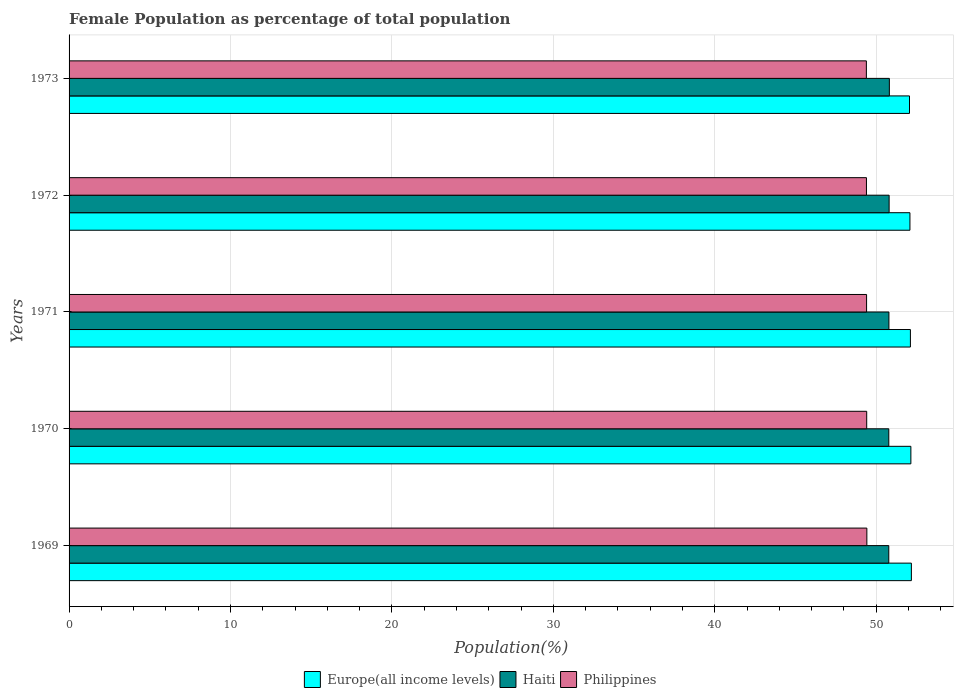How many different coloured bars are there?
Make the answer very short. 3. Are the number of bars per tick equal to the number of legend labels?
Provide a short and direct response. Yes. Are the number of bars on each tick of the Y-axis equal?
Provide a succinct answer. Yes. How many bars are there on the 5th tick from the bottom?
Keep it short and to the point. 3. In how many cases, is the number of bars for a given year not equal to the number of legend labels?
Make the answer very short. 0. What is the female population in in Haiti in 1970?
Your answer should be very brief. 50.78. Across all years, what is the maximum female population in in Philippines?
Give a very brief answer. 49.42. Across all years, what is the minimum female population in in Philippines?
Offer a terse response. 49.39. In which year was the female population in in Europe(all income levels) maximum?
Provide a succinct answer. 1969. In which year was the female population in in Philippines minimum?
Provide a short and direct response. 1973. What is the total female population in in Europe(all income levels) in the graph?
Make the answer very short. 260.58. What is the difference between the female population in in Philippines in 1971 and that in 1973?
Your answer should be compact. 0.01. What is the difference between the female population in in Philippines in 1973 and the female population in in Haiti in 1972?
Your answer should be very brief. -1.41. What is the average female population in in Europe(all income levels) per year?
Offer a terse response. 52.12. In the year 1969, what is the difference between the female population in in Europe(all income levels) and female population in in Haiti?
Offer a terse response. 1.4. In how many years, is the female population in in Philippines greater than 26 %?
Ensure brevity in your answer.  5. What is the ratio of the female population in in Philippines in 1969 to that in 1970?
Ensure brevity in your answer.  1. What is the difference between the highest and the second highest female population in in Philippines?
Your answer should be compact. 0.01. What is the difference between the highest and the lowest female population in in Haiti?
Give a very brief answer. 0.04. In how many years, is the female population in in Philippines greater than the average female population in in Philippines taken over all years?
Give a very brief answer. 2. What does the 2nd bar from the top in 1973 represents?
Your response must be concise. Haiti. What does the 2nd bar from the bottom in 1970 represents?
Your answer should be compact. Haiti. How many bars are there?
Give a very brief answer. 15. Are all the bars in the graph horizontal?
Ensure brevity in your answer.  Yes. How many years are there in the graph?
Ensure brevity in your answer.  5. What is the difference between two consecutive major ticks on the X-axis?
Keep it short and to the point. 10. Does the graph contain grids?
Ensure brevity in your answer.  Yes. How many legend labels are there?
Make the answer very short. 3. How are the legend labels stacked?
Your answer should be very brief. Horizontal. What is the title of the graph?
Your answer should be very brief. Female Population as percentage of total population. What is the label or title of the X-axis?
Your answer should be compact. Population(%). What is the label or title of the Y-axis?
Make the answer very short. Years. What is the Population(%) of Europe(all income levels) in 1969?
Offer a terse response. 52.18. What is the Population(%) of Haiti in 1969?
Provide a short and direct response. 50.78. What is the Population(%) in Philippines in 1969?
Make the answer very short. 49.42. What is the Population(%) of Europe(all income levels) in 1970?
Offer a very short reply. 52.15. What is the Population(%) in Haiti in 1970?
Your response must be concise. 50.78. What is the Population(%) of Philippines in 1970?
Your answer should be compact. 49.41. What is the Population(%) in Europe(all income levels) in 1971?
Ensure brevity in your answer.  52.12. What is the Population(%) in Haiti in 1971?
Your answer should be very brief. 50.79. What is the Population(%) in Philippines in 1971?
Offer a very short reply. 49.4. What is the Population(%) of Europe(all income levels) in 1972?
Provide a succinct answer. 52.09. What is the Population(%) of Haiti in 1972?
Provide a succinct answer. 50.8. What is the Population(%) in Philippines in 1972?
Give a very brief answer. 49.39. What is the Population(%) of Europe(all income levels) in 1973?
Your answer should be compact. 52.06. What is the Population(%) of Haiti in 1973?
Keep it short and to the point. 50.81. What is the Population(%) of Philippines in 1973?
Your answer should be compact. 49.39. Across all years, what is the maximum Population(%) in Europe(all income levels)?
Give a very brief answer. 52.18. Across all years, what is the maximum Population(%) in Haiti?
Your answer should be very brief. 50.81. Across all years, what is the maximum Population(%) of Philippines?
Offer a very short reply. 49.42. Across all years, what is the minimum Population(%) of Europe(all income levels)?
Ensure brevity in your answer.  52.06. Across all years, what is the minimum Population(%) of Haiti?
Provide a succinct answer. 50.78. Across all years, what is the minimum Population(%) of Philippines?
Ensure brevity in your answer.  49.39. What is the total Population(%) of Europe(all income levels) in the graph?
Keep it short and to the point. 260.58. What is the total Population(%) in Haiti in the graph?
Provide a succinct answer. 253.95. What is the total Population(%) of Philippines in the graph?
Give a very brief answer. 247.01. What is the difference between the Population(%) of Europe(all income levels) in 1969 and that in 1970?
Give a very brief answer. 0.03. What is the difference between the Population(%) in Haiti in 1969 and that in 1970?
Provide a short and direct response. -0. What is the difference between the Population(%) in Philippines in 1969 and that in 1970?
Provide a short and direct response. 0.01. What is the difference between the Population(%) in Europe(all income levels) in 1969 and that in 1971?
Provide a short and direct response. 0.06. What is the difference between the Population(%) in Haiti in 1969 and that in 1971?
Your response must be concise. -0.01. What is the difference between the Population(%) in Philippines in 1969 and that in 1971?
Offer a very short reply. 0.02. What is the difference between the Population(%) of Europe(all income levels) in 1969 and that in 1972?
Ensure brevity in your answer.  0.09. What is the difference between the Population(%) in Haiti in 1969 and that in 1972?
Make the answer very short. -0.02. What is the difference between the Population(%) of Philippines in 1969 and that in 1972?
Offer a terse response. 0.02. What is the difference between the Population(%) in Europe(all income levels) in 1969 and that in 1973?
Provide a succinct answer. 0.12. What is the difference between the Population(%) of Haiti in 1969 and that in 1973?
Offer a very short reply. -0.04. What is the difference between the Population(%) in Philippines in 1969 and that in 1973?
Offer a very short reply. 0.03. What is the difference between the Population(%) in Europe(all income levels) in 1970 and that in 1971?
Give a very brief answer. 0.03. What is the difference between the Population(%) of Haiti in 1970 and that in 1971?
Your answer should be compact. -0.01. What is the difference between the Population(%) in Philippines in 1970 and that in 1971?
Provide a succinct answer. 0.01. What is the difference between the Population(%) in Europe(all income levels) in 1970 and that in 1972?
Your answer should be compact. 0.06. What is the difference between the Population(%) in Haiti in 1970 and that in 1972?
Provide a short and direct response. -0.02. What is the difference between the Population(%) in Philippines in 1970 and that in 1972?
Provide a succinct answer. 0.02. What is the difference between the Population(%) of Europe(all income levels) in 1970 and that in 1973?
Your answer should be very brief. 0.09. What is the difference between the Population(%) in Haiti in 1970 and that in 1973?
Offer a very short reply. -0.03. What is the difference between the Population(%) of Philippines in 1970 and that in 1973?
Provide a short and direct response. 0.02. What is the difference between the Population(%) in Europe(all income levels) in 1971 and that in 1972?
Offer a terse response. 0.03. What is the difference between the Population(%) of Haiti in 1971 and that in 1972?
Provide a succinct answer. -0.01. What is the difference between the Population(%) in Philippines in 1971 and that in 1972?
Your answer should be very brief. 0.01. What is the difference between the Population(%) of Europe(all income levels) in 1971 and that in 1973?
Give a very brief answer. 0.06. What is the difference between the Population(%) in Haiti in 1971 and that in 1973?
Make the answer very short. -0.03. What is the difference between the Population(%) of Philippines in 1971 and that in 1973?
Your answer should be very brief. 0.01. What is the difference between the Population(%) in Europe(all income levels) in 1972 and that in 1973?
Give a very brief answer. 0.03. What is the difference between the Population(%) in Haiti in 1972 and that in 1973?
Provide a short and direct response. -0.01. What is the difference between the Population(%) of Philippines in 1972 and that in 1973?
Make the answer very short. 0.01. What is the difference between the Population(%) in Europe(all income levels) in 1969 and the Population(%) in Haiti in 1970?
Provide a short and direct response. 1.4. What is the difference between the Population(%) of Europe(all income levels) in 1969 and the Population(%) of Philippines in 1970?
Offer a terse response. 2.77. What is the difference between the Population(%) in Haiti in 1969 and the Population(%) in Philippines in 1970?
Your response must be concise. 1.37. What is the difference between the Population(%) of Europe(all income levels) in 1969 and the Population(%) of Haiti in 1971?
Provide a short and direct response. 1.39. What is the difference between the Population(%) of Europe(all income levels) in 1969 and the Population(%) of Philippines in 1971?
Offer a terse response. 2.78. What is the difference between the Population(%) in Haiti in 1969 and the Population(%) in Philippines in 1971?
Make the answer very short. 1.38. What is the difference between the Population(%) of Europe(all income levels) in 1969 and the Population(%) of Haiti in 1972?
Keep it short and to the point. 1.38. What is the difference between the Population(%) of Europe(all income levels) in 1969 and the Population(%) of Philippines in 1972?
Your response must be concise. 2.78. What is the difference between the Population(%) of Haiti in 1969 and the Population(%) of Philippines in 1972?
Your answer should be very brief. 1.38. What is the difference between the Population(%) of Europe(all income levels) in 1969 and the Population(%) of Haiti in 1973?
Offer a very short reply. 1.36. What is the difference between the Population(%) of Europe(all income levels) in 1969 and the Population(%) of Philippines in 1973?
Your answer should be very brief. 2.79. What is the difference between the Population(%) of Haiti in 1969 and the Population(%) of Philippines in 1973?
Give a very brief answer. 1.39. What is the difference between the Population(%) in Europe(all income levels) in 1970 and the Population(%) in Haiti in 1971?
Make the answer very short. 1.36. What is the difference between the Population(%) in Europe(all income levels) in 1970 and the Population(%) in Philippines in 1971?
Offer a terse response. 2.74. What is the difference between the Population(%) of Haiti in 1970 and the Population(%) of Philippines in 1971?
Make the answer very short. 1.38. What is the difference between the Population(%) in Europe(all income levels) in 1970 and the Population(%) in Haiti in 1972?
Make the answer very short. 1.35. What is the difference between the Population(%) of Europe(all income levels) in 1970 and the Population(%) of Philippines in 1972?
Provide a succinct answer. 2.75. What is the difference between the Population(%) of Haiti in 1970 and the Population(%) of Philippines in 1972?
Offer a very short reply. 1.38. What is the difference between the Population(%) in Europe(all income levels) in 1970 and the Population(%) in Haiti in 1973?
Give a very brief answer. 1.33. What is the difference between the Population(%) in Europe(all income levels) in 1970 and the Population(%) in Philippines in 1973?
Offer a very short reply. 2.76. What is the difference between the Population(%) of Haiti in 1970 and the Population(%) of Philippines in 1973?
Keep it short and to the point. 1.39. What is the difference between the Population(%) of Europe(all income levels) in 1971 and the Population(%) of Haiti in 1972?
Make the answer very short. 1.32. What is the difference between the Population(%) in Europe(all income levels) in 1971 and the Population(%) in Philippines in 1972?
Your answer should be compact. 2.72. What is the difference between the Population(%) of Haiti in 1971 and the Population(%) of Philippines in 1972?
Offer a terse response. 1.39. What is the difference between the Population(%) of Europe(all income levels) in 1971 and the Population(%) of Haiti in 1973?
Your answer should be very brief. 1.3. What is the difference between the Population(%) in Europe(all income levels) in 1971 and the Population(%) in Philippines in 1973?
Give a very brief answer. 2.73. What is the difference between the Population(%) in Haiti in 1971 and the Population(%) in Philippines in 1973?
Provide a succinct answer. 1.4. What is the difference between the Population(%) in Europe(all income levels) in 1972 and the Population(%) in Haiti in 1973?
Provide a short and direct response. 1.27. What is the difference between the Population(%) in Europe(all income levels) in 1972 and the Population(%) in Philippines in 1973?
Offer a very short reply. 2.7. What is the difference between the Population(%) in Haiti in 1972 and the Population(%) in Philippines in 1973?
Provide a succinct answer. 1.41. What is the average Population(%) in Europe(all income levels) per year?
Ensure brevity in your answer.  52.12. What is the average Population(%) of Haiti per year?
Offer a very short reply. 50.79. What is the average Population(%) in Philippines per year?
Ensure brevity in your answer.  49.4. In the year 1969, what is the difference between the Population(%) in Europe(all income levels) and Population(%) in Philippines?
Keep it short and to the point. 2.76. In the year 1969, what is the difference between the Population(%) of Haiti and Population(%) of Philippines?
Keep it short and to the point. 1.36. In the year 1970, what is the difference between the Population(%) of Europe(all income levels) and Population(%) of Haiti?
Your answer should be compact. 1.37. In the year 1970, what is the difference between the Population(%) in Europe(all income levels) and Population(%) in Philippines?
Give a very brief answer. 2.74. In the year 1970, what is the difference between the Population(%) in Haiti and Population(%) in Philippines?
Your answer should be very brief. 1.37. In the year 1971, what is the difference between the Population(%) in Europe(all income levels) and Population(%) in Haiti?
Provide a short and direct response. 1.33. In the year 1971, what is the difference between the Population(%) in Europe(all income levels) and Population(%) in Philippines?
Ensure brevity in your answer.  2.71. In the year 1971, what is the difference between the Population(%) in Haiti and Population(%) in Philippines?
Your response must be concise. 1.38. In the year 1972, what is the difference between the Population(%) of Europe(all income levels) and Population(%) of Haiti?
Make the answer very short. 1.29. In the year 1972, what is the difference between the Population(%) of Europe(all income levels) and Population(%) of Philippines?
Your answer should be very brief. 2.69. In the year 1972, what is the difference between the Population(%) of Haiti and Population(%) of Philippines?
Your answer should be compact. 1.4. In the year 1973, what is the difference between the Population(%) of Europe(all income levels) and Population(%) of Haiti?
Your response must be concise. 1.25. In the year 1973, what is the difference between the Population(%) of Europe(all income levels) and Population(%) of Philippines?
Your answer should be compact. 2.67. In the year 1973, what is the difference between the Population(%) of Haiti and Population(%) of Philippines?
Your answer should be very brief. 1.42. What is the ratio of the Population(%) in Europe(all income levels) in 1969 to that in 1970?
Give a very brief answer. 1. What is the ratio of the Population(%) in Haiti in 1969 to that in 1970?
Make the answer very short. 1. What is the ratio of the Population(%) in Europe(all income levels) in 1969 to that in 1971?
Provide a short and direct response. 1. What is the ratio of the Population(%) in Haiti in 1969 to that in 1972?
Offer a very short reply. 1. What is the ratio of the Population(%) in Philippines in 1969 to that in 1972?
Ensure brevity in your answer.  1. What is the ratio of the Population(%) in Europe(all income levels) in 1969 to that in 1973?
Ensure brevity in your answer.  1. What is the ratio of the Population(%) of Haiti in 1969 to that in 1973?
Offer a terse response. 1. What is the ratio of the Population(%) in Philippines in 1969 to that in 1973?
Provide a succinct answer. 1. What is the ratio of the Population(%) in Haiti in 1970 to that in 1971?
Your answer should be very brief. 1. What is the ratio of the Population(%) of Haiti in 1970 to that in 1972?
Give a very brief answer. 1. What is the ratio of the Population(%) in Philippines in 1970 to that in 1972?
Make the answer very short. 1. What is the ratio of the Population(%) of Haiti in 1970 to that in 1973?
Keep it short and to the point. 1. What is the ratio of the Population(%) of Philippines in 1970 to that in 1973?
Your response must be concise. 1. What is the ratio of the Population(%) of Europe(all income levels) in 1971 to that in 1972?
Provide a short and direct response. 1. What is the ratio of the Population(%) in Philippines in 1971 to that in 1972?
Offer a very short reply. 1. What is the ratio of the Population(%) of Europe(all income levels) in 1971 to that in 1973?
Ensure brevity in your answer.  1. What is the ratio of the Population(%) in Haiti in 1971 to that in 1973?
Give a very brief answer. 1. What is the ratio of the Population(%) of Europe(all income levels) in 1972 to that in 1973?
Make the answer very short. 1. What is the ratio of the Population(%) of Haiti in 1972 to that in 1973?
Offer a very short reply. 1. What is the difference between the highest and the second highest Population(%) of Europe(all income levels)?
Give a very brief answer. 0.03. What is the difference between the highest and the second highest Population(%) in Haiti?
Ensure brevity in your answer.  0.01. What is the difference between the highest and the second highest Population(%) in Philippines?
Give a very brief answer. 0.01. What is the difference between the highest and the lowest Population(%) of Europe(all income levels)?
Provide a short and direct response. 0.12. What is the difference between the highest and the lowest Population(%) in Haiti?
Make the answer very short. 0.04. What is the difference between the highest and the lowest Population(%) in Philippines?
Offer a very short reply. 0.03. 